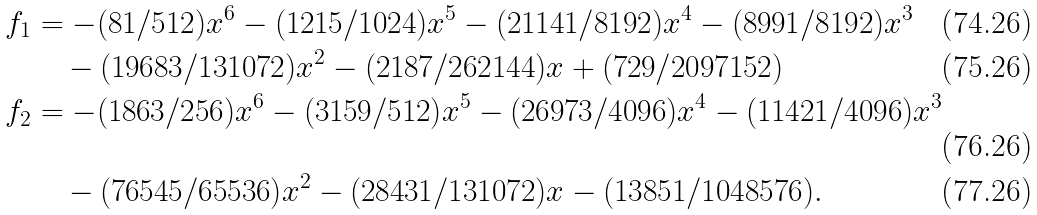Convert formula to latex. <formula><loc_0><loc_0><loc_500><loc_500>f _ { 1 } & = - ( 8 1 / 5 1 2 ) x ^ { 6 } - ( 1 2 1 5 / 1 0 2 4 ) x ^ { 5 } - ( 2 1 1 4 1 / 8 1 9 2 ) x ^ { 4 } - ( 8 9 9 1 / 8 1 9 2 ) x ^ { 3 } \\ & \quad - ( 1 9 6 8 3 / 1 3 1 0 7 2 ) x ^ { 2 } - ( 2 1 8 7 / 2 6 2 1 4 4 ) x + ( 7 2 9 / 2 0 9 7 1 5 2 ) \\ f _ { 2 } & = - ( 1 8 6 3 / 2 5 6 ) x ^ { 6 } - ( 3 1 5 9 / 5 1 2 ) x ^ { 5 } - ( 2 6 9 7 3 / 4 0 9 6 ) x ^ { 4 } - ( 1 1 4 2 1 / 4 0 9 6 ) x ^ { 3 } \\ & \quad - ( 7 6 5 4 5 / 6 5 5 3 6 ) x ^ { 2 } - ( 2 8 4 3 1 / 1 3 1 0 7 2 ) x - ( 1 3 8 5 1 / 1 0 4 8 5 7 6 ) .</formula> 